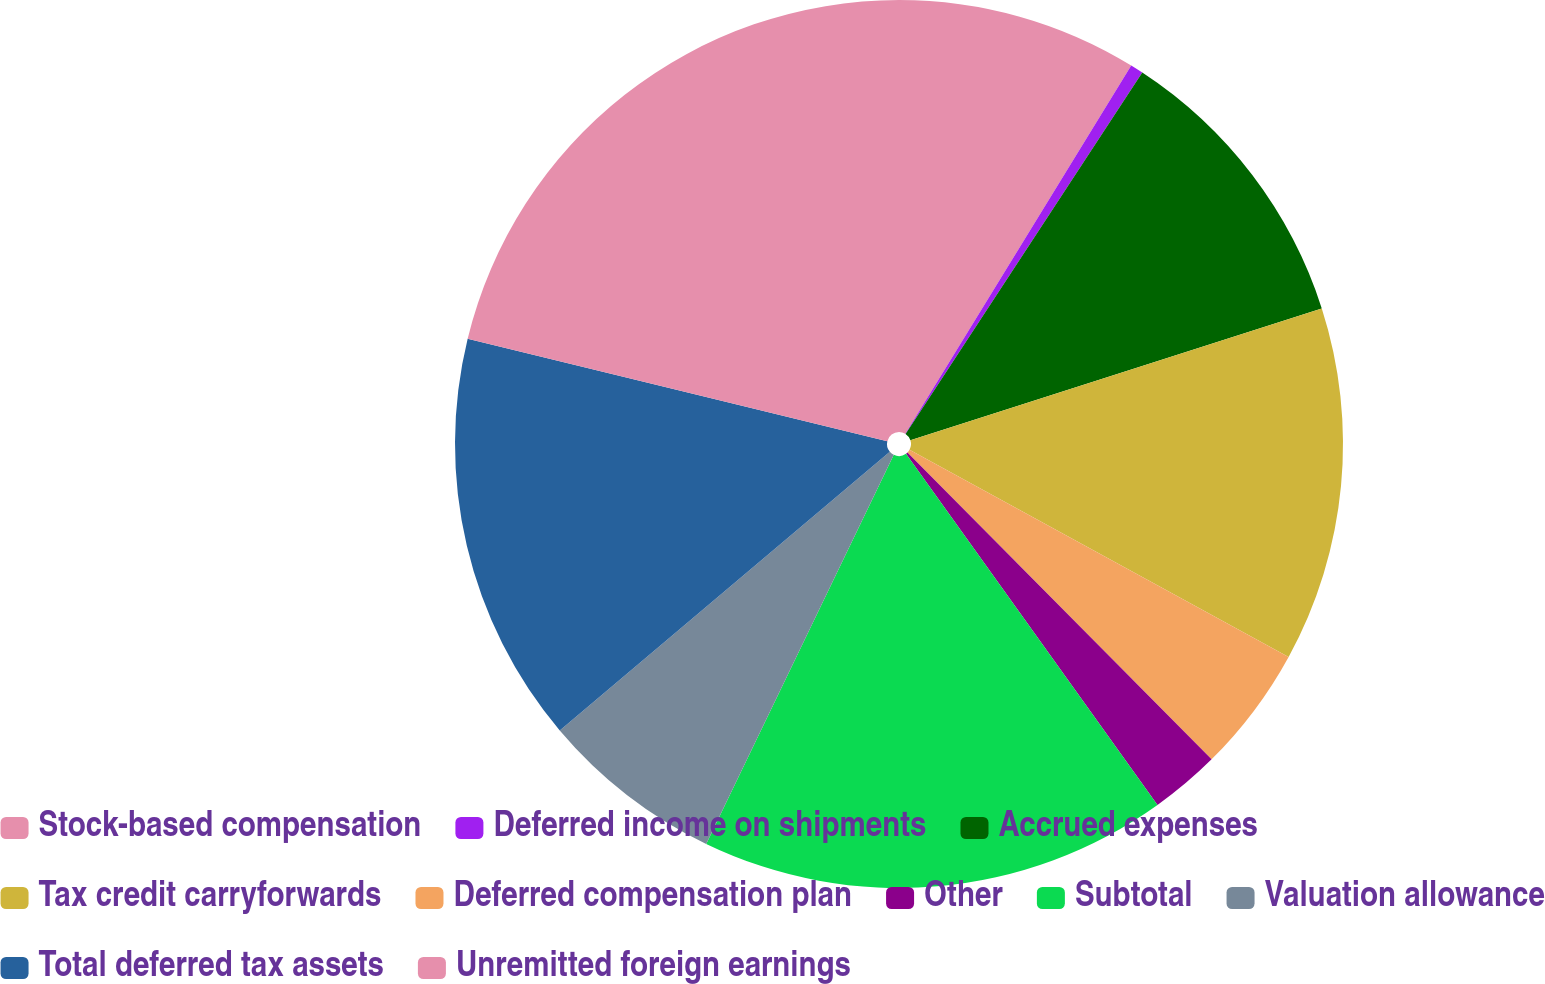Convert chart to OTSL. <chart><loc_0><loc_0><loc_500><loc_500><pie_chart><fcel>Stock-based compensation<fcel>Deferred income on shipments<fcel>Accrued expenses<fcel>Tax credit carryforwards<fcel>Deferred compensation plan<fcel>Other<fcel>Subtotal<fcel>Valuation allowance<fcel>Total deferred tax assets<fcel>Unremitted foreign earnings<nl><fcel>8.76%<fcel>0.47%<fcel>10.83%<fcel>12.9%<fcel>4.61%<fcel>2.54%<fcel>17.04%<fcel>6.69%<fcel>14.97%<fcel>21.19%<nl></chart> 